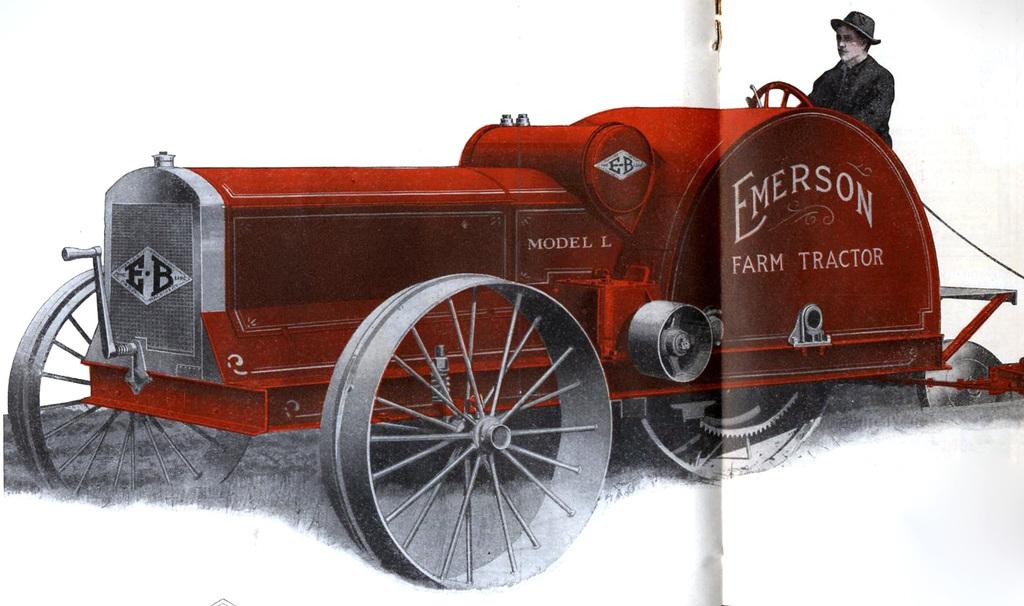What is the main subject of the image? The main subject of the image is a painting. What is depicted in the painting? The painting depicts a person and a vehicle. What type of meat is being cooked in the painting? There is no meat present in the painting; it depicts a person and a vehicle. Who is the person's partner in the painting? There is no indication of a partner in the painting; it only depicts a person and a vehicle. 